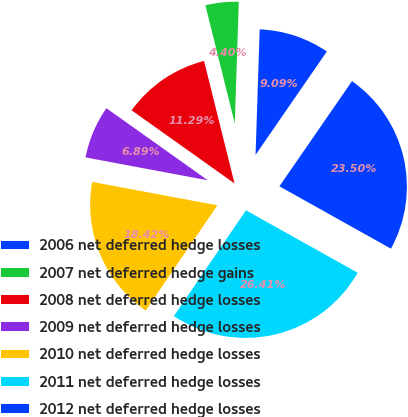Convert chart. <chart><loc_0><loc_0><loc_500><loc_500><pie_chart><fcel>2006 net deferred hedge losses<fcel>2007 net deferred hedge gains<fcel>2008 net deferred hedge losses<fcel>2009 net deferred hedge losses<fcel>2010 net deferred hedge losses<fcel>2011 net deferred hedge losses<fcel>2012 net deferred hedge losses<nl><fcel>9.09%<fcel>4.4%<fcel>11.29%<fcel>6.89%<fcel>18.42%<fcel>26.41%<fcel>23.5%<nl></chart> 